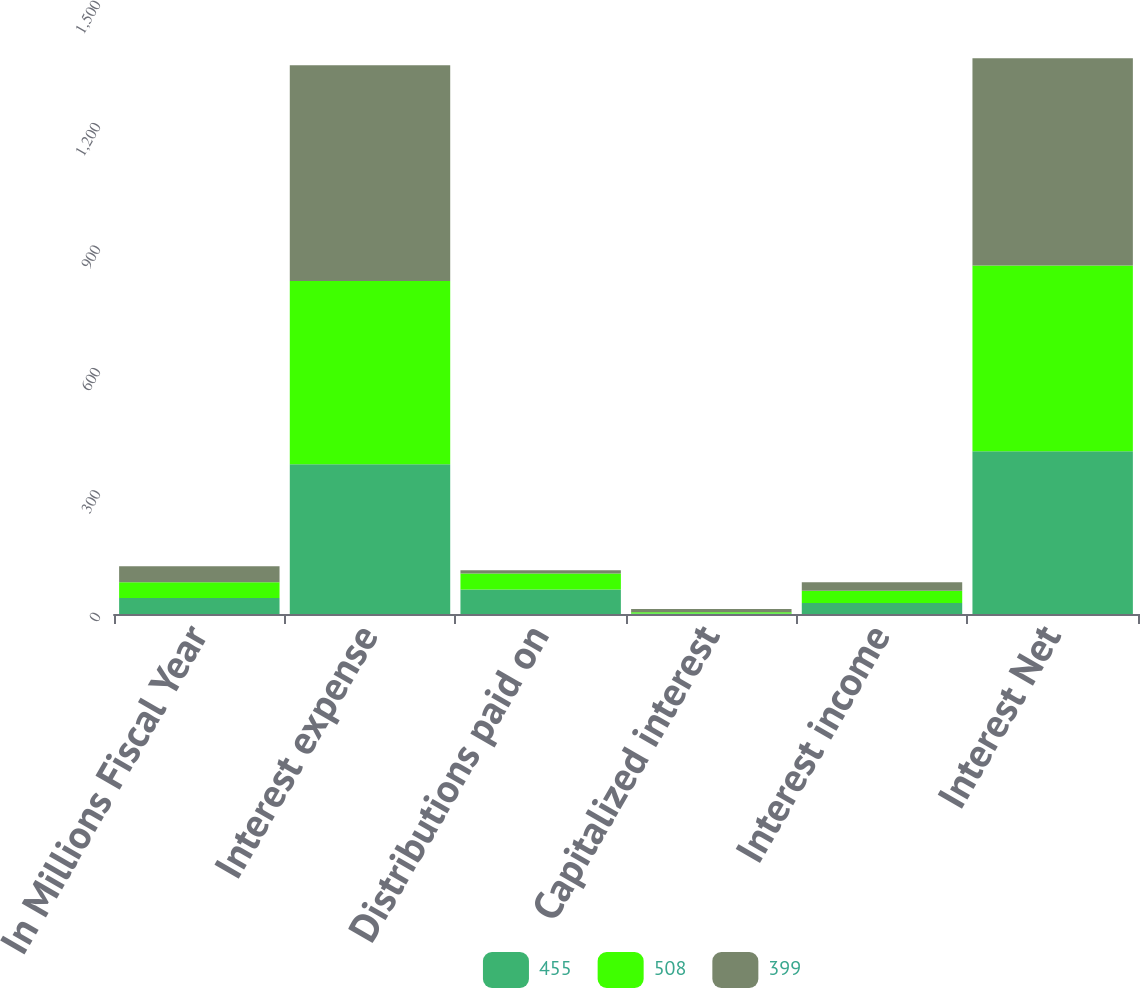Convert chart. <chart><loc_0><loc_0><loc_500><loc_500><stacked_bar_chart><ecel><fcel>In Millions Fiscal Year<fcel>Interest expense<fcel>Distributions paid on<fcel>Capitalized interest<fcel>Interest income<fcel>Interest Net<nl><fcel>455<fcel>39<fcel>367<fcel>60<fcel>1<fcel>27<fcel>399<nl><fcel>508<fcel>39<fcel>449<fcel>39<fcel>3<fcel>30<fcel>455<nl><fcel>399<fcel>39<fcel>529<fcel>8<fcel>8<fcel>21<fcel>508<nl></chart> 